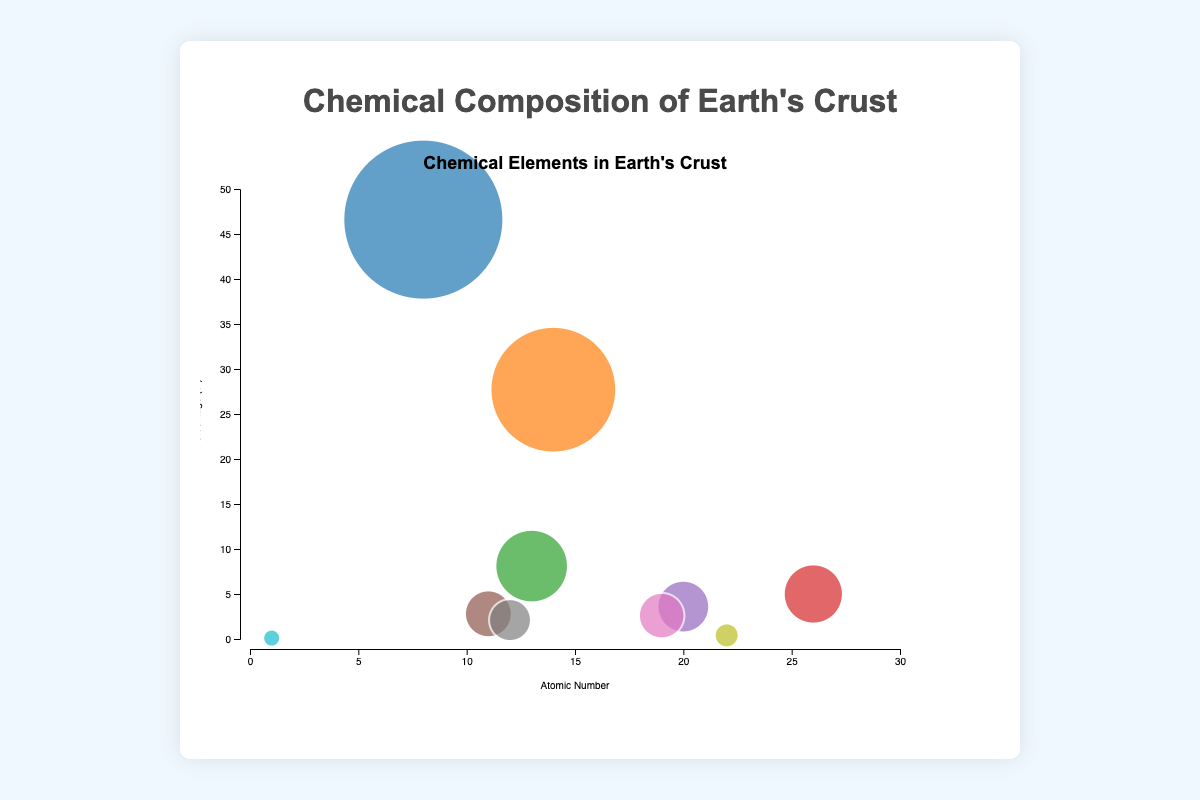What is the title of the chart? The title is located at the top of the chart area and is large and centered. It reads "Chemical Elements in Earth's Crust."
Answer: Chemical Elements in Earth's Crust Which element is represented by the largest bubble? The size of each bubble corresponds to the percentage of the element in the Earth's crust. The largest bubble represents Oxygen, which has a percentage of 46.6%.
Answer: Oxygen What is the atomic number of Silicon, and what percentage does it make up? The chart provides a tooltip with details for each element. Silicon has an atomic number of 14 and makes up 27.7% of the Earth's crust.
Answer: 14, 27.7% Which element has the smallest bubble and what is its percentage? The smallest bubble represents Hydrogen, with a percentage of 0.1% in the Earth's crust. This can be determined by looking at the bubble with the smallest radius.
Answer: Hydrogen, 0.1% Which two elements together make up over 70% of the Earth's crust? Sum the percentages of Oxygen (46.6%) and Silicon (27.7%). The total is 46.6 + 27.7 = 74.3%, which is over 70%.
Answer: Oxygen and Silicon Between Iron and Calcium, which element has the higher atomic number and how much higher is it? Iron has an atomic number of 26, and Calcium has an atomic number of 20. The difference is 26 - 20 = 6. Therefore, Iron has a higher atomic number by 6.
Answer: Iron, 6 Which element has a larger bubble radius: Potassium or Sodium? Comparing the size of the bubbles, Sodium makes up 2.8%, and Potassium 2.6%. Sodium's bubble is slightly larger, indicating it has a larger percentage and thus a larger radius.
Answer: Sodium What does the vertical axis represent, and what is its range? The vertical axis represents the percentage composition of the elements in the Earth's crust. The range is from 0 to 50%.
Answer: Percentage, 0 to 50% Which element has a higher percentage, Magnesium or Aluminum, and by how much? Magnesium has a percentage of 2.1%, and Aluminum has 8.1%. The difference is 8.1 - 2.1 = 6.0%.
Answer: Aluminum, 6.0% Arrange the elements Oxygen, Iron, and Hydrogen in descending order of their bubble size. Oxygen has a percentage of 46.6%, Iron has 5.0%, and Hydrogen has 0.1%. Arranging them in descending order of their bubble size gives: Oxygen, Iron, Hydrogen.
Answer: Oxygen, Iron, Hydrogen 